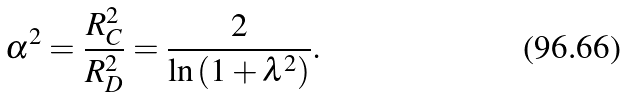<formula> <loc_0><loc_0><loc_500><loc_500>\alpha ^ { 2 } = \frac { R _ { C } ^ { 2 } } { R _ { D } ^ { 2 } } = \frac { 2 } { \ln \left ( 1 + \lambda ^ { 2 } \right ) } .</formula> 